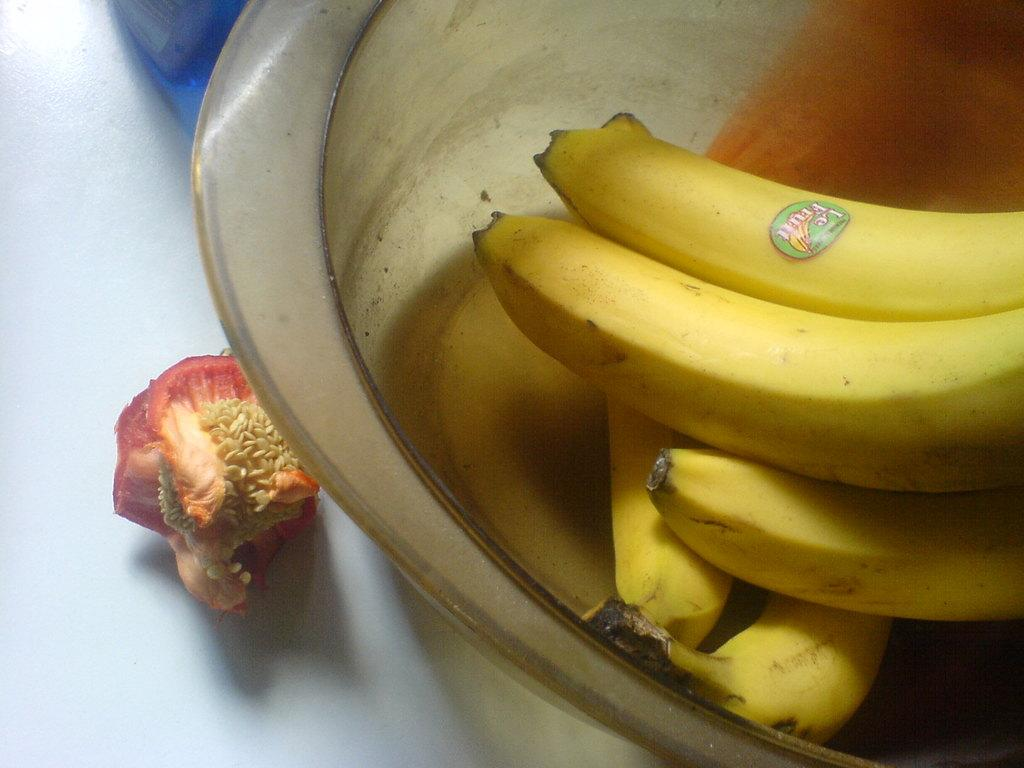What is in the bowl that is visible in the foreground of the image? There is a bowl with bananas in the foreground of the image. Can you describe any other fruit visible in the image? There appears to be a fruit on the left side of the image. What type of caption is written below the bowl of bananas in the image? There is no caption written below the bowl of bananas in the image. 